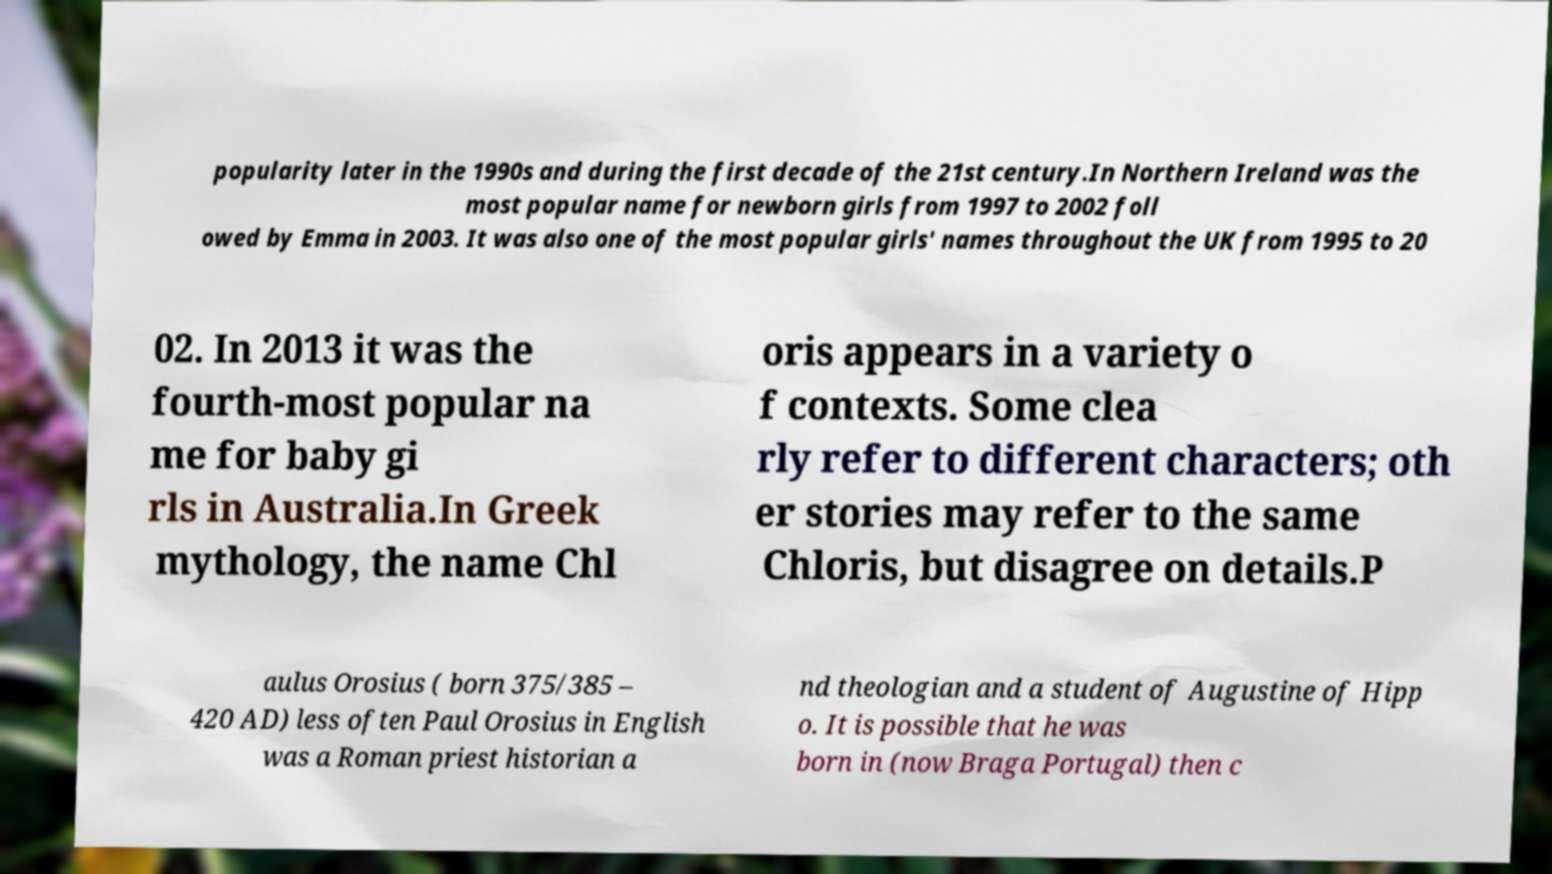There's text embedded in this image that I need extracted. Can you transcribe it verbatim? popularity later in the 1990s and during the first decade of the 21st century.In Northern Ireland was the most popular name for newborn girls from 1997 to 2002 foll owed by Emma in 2003. It was also one of the most popular girls' names throughout the UK from 1995 to 20 02. In 2013 it was the fourth-most popular na me for baby gi rls in Australia.In Greek mythology, the name Chl oris appears in a variety o f contexts. Some clea rly refer to different characters; oth er stories may refer to the same Chloris, but disagree on details.P aulus Orosius ( born 375/385 – 420 AD) less often Paul Orosius in English was a Roman priest historian a nd theologian and a student of Augustine of Hipp o. It is possible that he was born in (now Braga Portugal) then c 